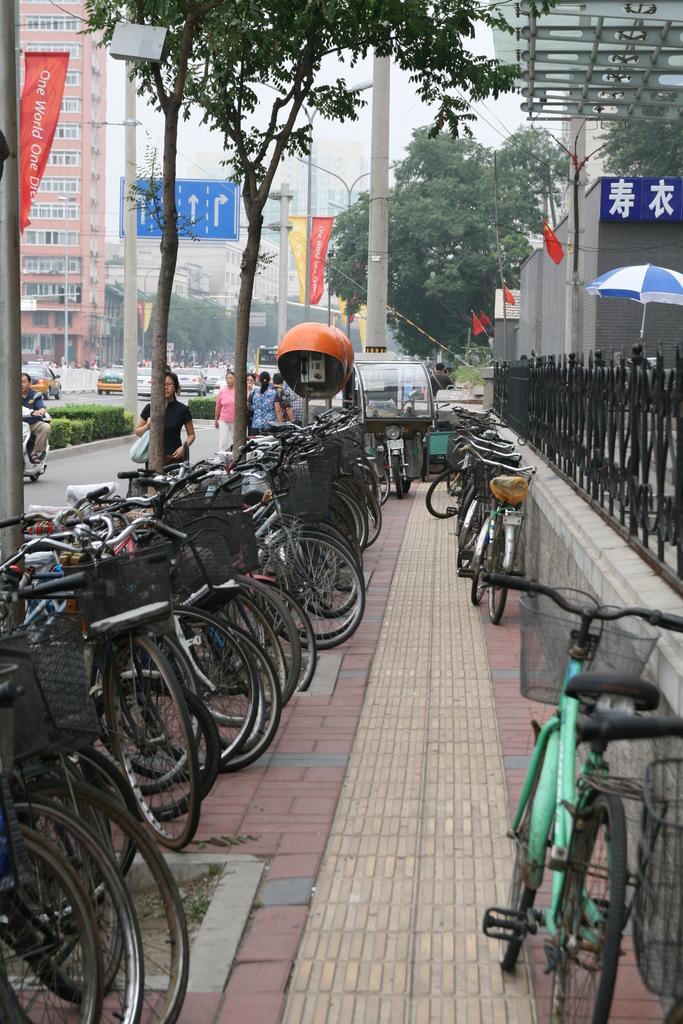Describe this image in one or two sentences. In this image we can see many bicycles parked on the path. We can also see the trees, buildings, poles, flags, sign board and also the vehicles. We can also see the people, plants and also the road. Sky is also visible. On the right there is an umbrella and also the fencing wall. 